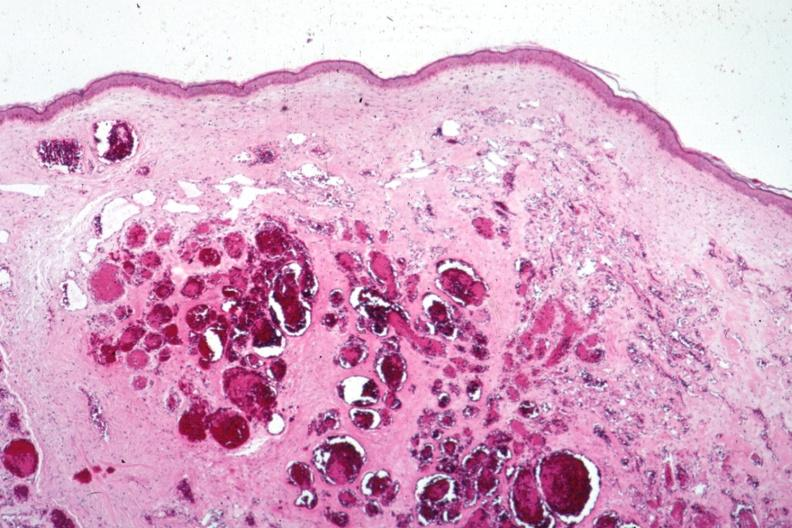does hand show typical cavernous lesion?
Answer the question using a single word or phrase. No 